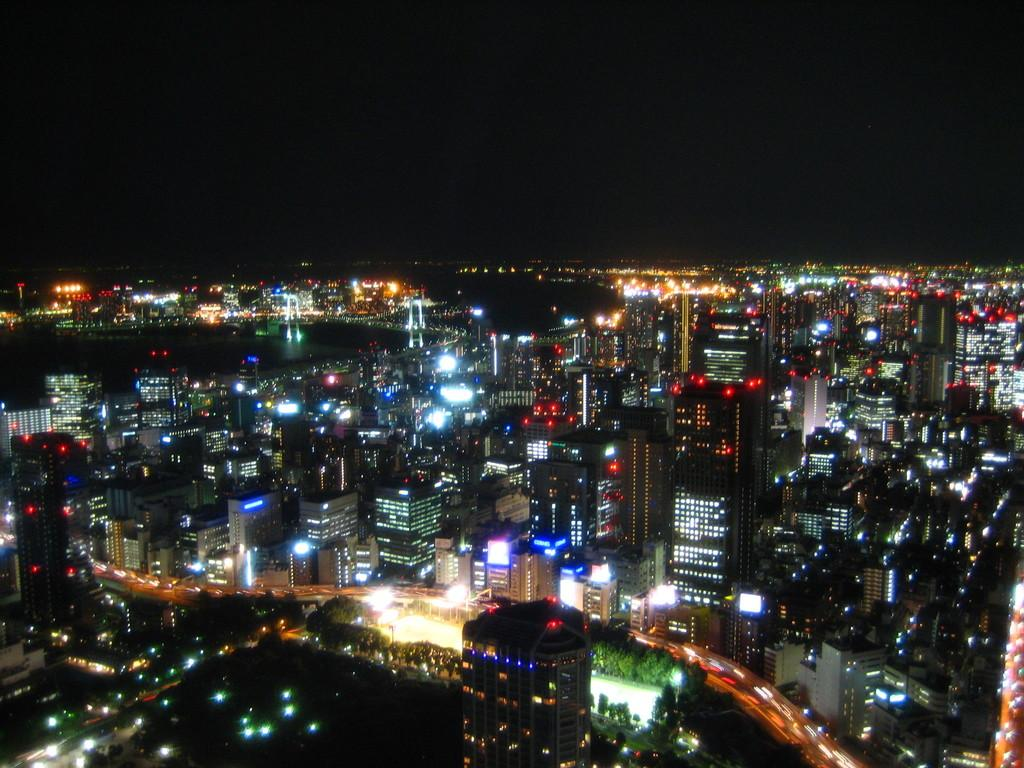What structures are located in the middle of the image? There are buildings in the middle of the image. What else can be seen in the middle of the image besides buildings? There are trees, lights, and water in the middle of the image. Where is the cat located in the image? There is no cat present in the image. What type of ear is visible in the image? There are no ears visible in the image. 